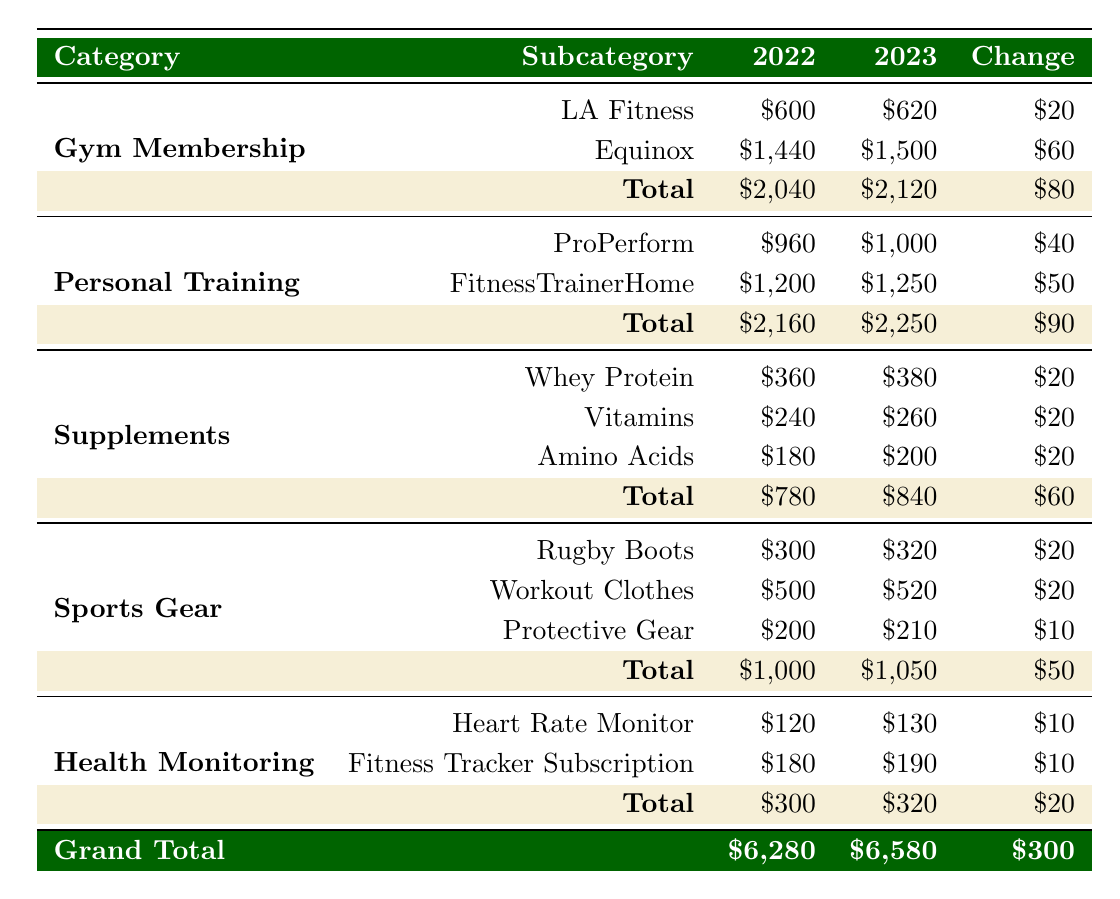What is the total expenditure on gym membership in 2023? In the gym membership category for 2023, the totals for LA Fitness and Equinox are given as $620 and $1500 respectively. To find the total, we simply sum these values: 620 + 1500 = 2120.
Answer: 2120 How much did Peter spend on supplements in total in 2022? The total expenditure on supplements in 2022 is displayed directly in the table as $780. There is no need for further calculation.
Answer: 780 What is the percentage increase in total personal training expenditure from 2022 to 2023? The total for personal training is $2160 in 2022 and $2250 in 2023. First, calculate the increase: 2250 - 2160 = 90. Then, to find the percentage increase: (90 / 2160) * 100 = 4.17%.
Answer: 4.17% Did the expenditure on health monitoring decrease from 2022 to 2023? Looking at the totals for health monitoring, $300 in 2022 and $320 in 2023, we see that the expenditure increased, not decreased. Therefore, the answer to this question is no.
Answer: No What is the average expenditure on supplements for both years combined? The total expenditure on supplements is $780 for 2022 and $840 for 2023. To find the combined total, we add these: 780 + 840 = 1620. To find the average, we divide by 2: 1620 / 2 = 810.
Answer: 810 Which category experienced the highest total expenditure in 2023? The total expenditures are: Gym Membership: $2120, Personal Training: $2250, Supplements: $840, Sports Gear: $1050, Health Monitoring: $320. The highest is Personal Training at $2250.
Answer: Personal Training What is the change in expenditure on sports gear from 2022 to 2023? The total for sports gear in 2022 is $1000 and in 2023 it is $1050. The change can be calculated as 1050 - 1000 = 50. Thus, the expenditure increased by $50.
Answer: 50 Was more money spent on fitness tracker subscriptions in 2023 than in 2022? In 2022, the expenditure on fitness tracker subscriptions was $180 and in 2023, it was $190. Since 190 is greater than 180, the answer is yes.
Answer: Yes 